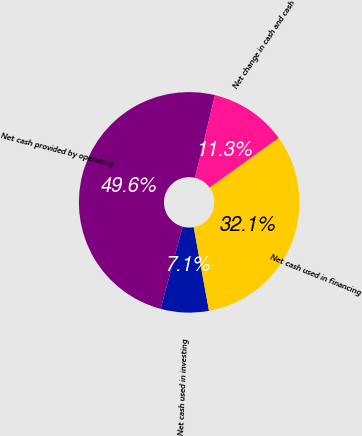Convert chart. <chart><loc_0><loc_0><loc_500><loc_500><pie_chart><fcel>Net cash provided by operating<fcel>Net cash used in investing<fcel>Net cash used in financing<fcel>Net change in cash and cash<nl><fcel>49.59%<fcel>7.05%<fcel>32.05%<fcel>11.3%<nl></chart> 